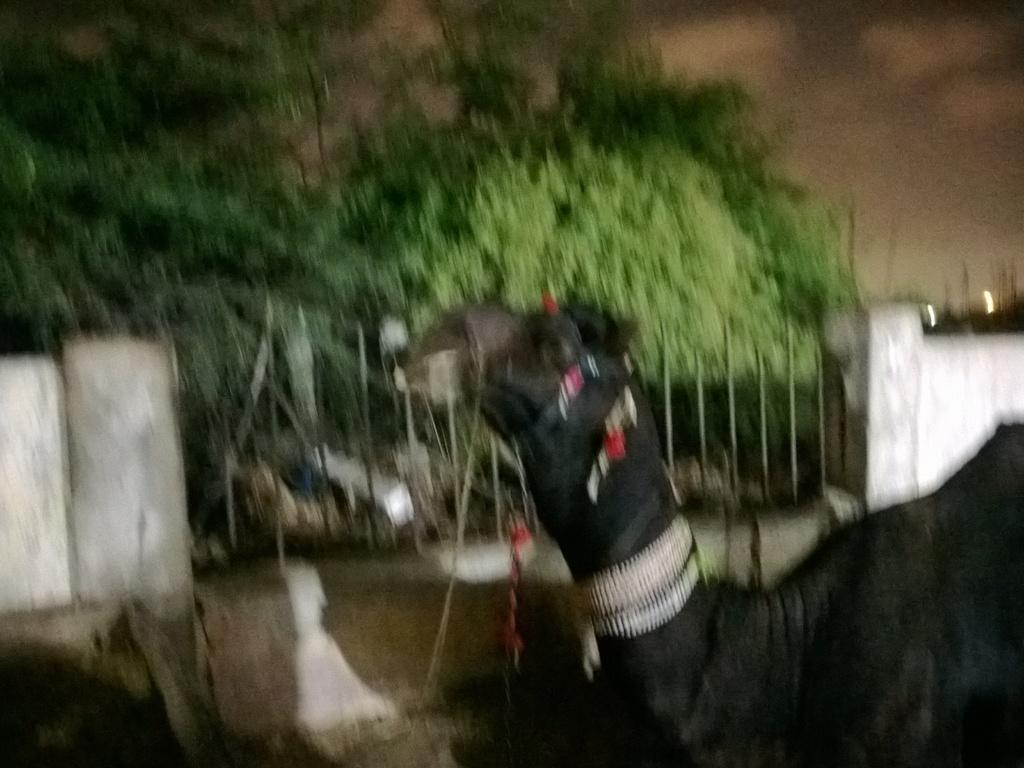What animal is in the front of the image? There is a camel in the front of the image. What can be seen in the background of the image? There are trees and a wall in the background of the image. What part of the sky is visible in the image? The sky is visible at the top right of the image. What type of food is the camel eating in the image? There is no food visible in the image, and the camel is not shown eating anything. 